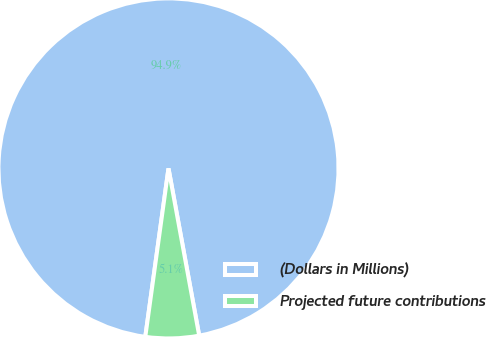<chart> <loc_0><loc_0><loc_500><loc_500><pie_chart><fcel>(Dollars in Millions)<fcel>Projected future contributions<nl><fcel>94.93%<fcel>5.07%<nl></chart> 